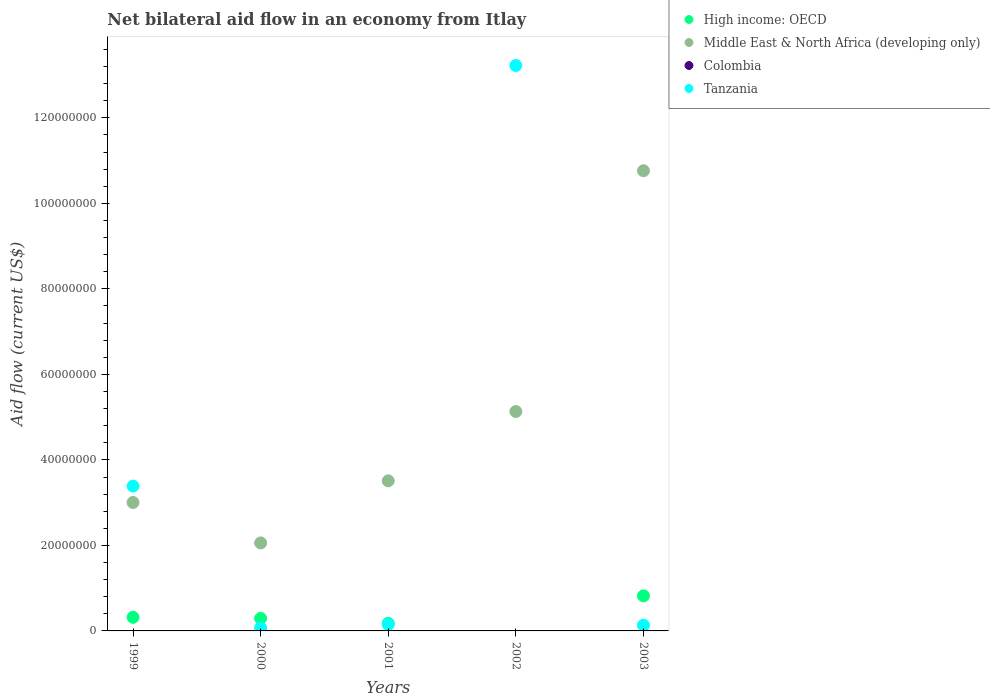How many different coloured dotlines are there?
Offer a terse response. 3. Across all years, what is the maximum net bilateral aid flow in High income: OECD?
Ensure brevity in your answer.  8.20e+06. Across all years, what is the minimum net bilateral aid flow in High income: OECD?
Your answer should be compact. 0. What is the total net bilateral aid flow in Tanzania in the graph?
Offer a very short reply. 1.70e+08. What is the difference between the net bilateral aid flow in Tanzania in 1999 and that in 2001?
Give a very brief answer. 3.24e+07. What is the difference between the net bilateral aid flow in High income: OECD in 2001 and the net bilateral aid flow in Colombia in 2000?
Give a very brief answer. 1.77e+06. What is the average net bilateral aid flow in Colombia per year?
Your response must be concise. 0. In the year 2003, what is the difference between the net bilateral aid flow in Tanzania and net bilateral aid flow in High income: OECD?
Your response must be concise. -6.86e+06. In how many years, is the net bilateral aid flow in Colombia greater than 80000000 US$?
Give a very brief answer. 0. What is the ratio of the net bilateral aid flow in Middle East & North Africa (developing only) in 2000 to that in 2003?
Your answer should be very brief. 0.19. Is the net bilateral aid flow in Tanzania in 2001 less than that in 2003?
Your answer should be very brief. No. Is the difference between the net bilateral aid flow in Tanzania in 2001 and 2003 greater than the difference between the net bilateral aid flow in High income: OECD in 2001 and 2003?
Ensure brevity in your answer.  Yes. What is the difference between the highest and the second highest net bilateral aid flow in High income: OECD?
Ensure brevity in your answer.  5.02e+06. What is the difference between the highest and the lowest net bilateral aid flow in Tanzania?
Your answer should be very brief. 1.32e+08. Is the sum of the net bilateral aid flow in Tanzania in 1999 and 2002 greater than the maximum net bilateral aid flow in High income: OECD across all years?
Your answer should be compact. Yes. Is it the case that in every year, the sum of the net bilateral aid flow in Colombia and net bilateral aid flow in High income: OECD  is greater than the sum of net bilateral aid flow in Tanzania and net bilateral aid flow in Middle East & North Africa (developing only)?
Offer a terse response. No. Does the net bilateral aid flow in Colombia monotonically increase over the years?
Give a very brief answer. No. Is the net bilateral aid flow in High income: OECD strictly less than the net bilateral aid flow in Colombia over the years?
Keep it short and to the point. No. How many years are there in the graph?
Give a very brief answer. 5. What is the difference between two consecutive major ticks on the Y-axis?
Your answer should be compact. 2.00e+07. Does the graph contain grids?
Ensure brevity in your answer.  No. Where does the legend appear in the graph?
Provide a short and direct response. Top right. How many legend labels are there?
Offer a terse response. 4. How are the legend labels stacked?
Ensure brevity in your answer.  Vertical. What is the title of the graph?
Your response must be concise. Net bilateral aid flow in an economy from Itlay. What is the label or title of the X-axis?
Ensure brevity in your answer.  Years. What is the Aid flow (current US$) in High income: OECD in 1999?
Keep it short and to the point. 3.18e+06. What is the Aid flow (current US$) of Middle East & North Africa (developing only) in 1999?
Your answer should be compact. 3.00e+07. What is the Aid flow (current US$) in Tanzania in 1999?
Offer a very short reply. 3.39e+07. What is the Aid flow (current US$) in High income: OECD in 2000?
Your answer should be compact. 2.94e+06. What is the Aid flow (current US$) of Middle East & North Africa (developing only) in 2000?
Give a very brief answer. 2.06e+07. What is the Aid flow (current US$) in Tanzania in 2000?
Ensure brevity in your answer.  6.90e+05. What is the Aid flow (current US$) in High income: OECD in 2001?
Your answer should be compact. 1.77e+06. What is the Aid flow (current US$) of Middle East & North Africa (developing only) in 2001?
Keep it short and to the point. 3.51e+07. What is the Aid flow (current US$) of Colombia in 2001?
Provide a succinct answer. 0. What is the Aid flow (current US$) of Tanzania in 2001?
Keep it short and to the point. 1.51e+06. What is the Aid flow (current US$) in Middle East & North Africa (developing only) in 2002?
Keep it short and to the point. 5.13e+07. What is the Aid flow (current US$) in Colombia in 2002?
Make the answer very short. 0. What is the Aid flow (current US$) of Tanzania in 2002?
Ensure brevity in your answer.  1.32e+08. What is the Aid flow (current US$) in High income: OECD in 2003?
Provide a short and direct response. 8.20e+06. What is the Aid flow (current US$) of Middle East & North Africa (developing only) in 2003?
Offer a very short reply. 1.08e+08. What is the Aid flow (current US$) in Colombia in 2003?
Offer a terse response. 0. What is the Aid flow (current US$) in Tanzania in 2003?
Provide a succinct answer. 1.34e+06. Across all years, what is the maximum Aid flow (current US$) in High income: OECD?
Your answer should be very brief. 8.20e+06. Across all years, what is the maximum Aid flow (current US$) of Middle East & North Africa (developing only)?
Your answer should be compact. 1.08e+08. Across all years, what is the maximum Aid flow (current US$) of Tanzania?
Make the answer very short. 1.32e+08. Across all years, what is the minimum Aid flow (current US$) of Middle East & North Africa (developing only)?
Provide a short and direct response. 2.06e+07. Across all years, what is the minimum Aid flow (current US$) in Tanzania?
Your answer should be compact. 6.90e+05. What is the total Aid flow (current US$) of High income: OECD in the graph?
Your response must be concise. 1.61e+07. What is the total Aid flow (current US$) in Middle East & North Africa (developing only) in the graph?
Keep it short and to the point. 2.45e+08. What is the total Aid flow (current US$) in Colombia in the graph?
Offer a terse response. 0. What is the total Aid flow (current US$) of Tanzania in the graph?
Offer a terse response. 1.70e+08. What is the difference between the Aid flow (current US$) of High income: OECD in 1999 and that in 2000?
Provide a short and direct response. 2.40e+05. What is the difference between the Aid flow (current US$) of Middle East & North Africa (developing only) in 1999 and that in 2000?
Offer a terse response. 9.46e+06. What is the difference between the Aid flow (current US$) of Tanzania in 1999 and that in 2000?
Your answer should be compact. 3.32e+07. What is the difference between the Aid flow (current US$) of High income: OECD in 1999 and that in 2001?
Provide a short and direct response. 1.41e+06. What is the difference between the Aid flow (current US$) of Middle East & North Africa (developing only) in 1999 and that in 2001?
Offer a terse response. -5.06e+06. What is the difference between the Aid flow (current US$) in Tanzania in 1999 and that in 2001?
Make the answer very short. 3.24e+07. What is the difference between the Aid flow (current US$) of Middle East & North Africa (developing only) in 1999 and that in 2002?
Ensure brevity in your answer.  -2.13e+07. What is the difference between the Aid flow (current US$) in Tanzania in 1999 and that in 2002?
Offer a terse response. -9.84e+07. What is the difference between the Aid flow (current US$) of High income: OECD in 1999 and that in 2003?
Keep it short and to the point. -5.02e+06. What is the difference between the Aid flow (current US$) in Middle East & North Africa (developing only) in 1999 and that in 2003?
Your answer should be very brief. -7.76e+07. What is the difference between the Aid flow (current US$) of Tanzania in 1999 and that in 2003?
Offer a terse response. 3.25e+07. What is the difference between the Aid flow (current US$) in High income: OECD in 2000 and that in 2001?
Keep it short and to the point. 1.17e+06. What is the difference between the Aid flow (current US$) of Middle East & North Africa (developing only) in 2000 and that in 2001?
Make the answer very short. -1.45e+07. What is the difference between the Aid flow (current US$) in Tanzania in 2000 and that in 2001?
Keep it short and to the point. -8.20e+05. What is the difference between the Aid flow (current US$) of Middle East & North Africa (developing only) in 2000 and that in 2002?
Provide a succinct answer. -3.07e+07. What is the difference between the Aid flow (current US$) of Tanzania in 2000 and that in 2002?
Give a very brief answer. -1.32e+08. What is the difference between the Aid flow (current US$) of High income: OECD in 2000 and that in 2003?
Give a very brief answer. -5.26e+06. What is the difference between the Aid flow (current US$) of Middle East & North Africa (developing only) in 2000 and that in 2003?
Your response must be concise. -8.70e+07. What is the difference between the Aid flow (current US$) of Tanzania in 2000 and that in 2003?
Offer a terse response. -6.50e+05. What is the difference between the Aid flow (current US$) of Middle East & North Africa (developing only) in 2001 and that in 2002?
Your answer should be very brief. -1.62e+07. What is the difference between the Aid flow (current US$) in Tanzania in 2001 and that in 2002?
Make the answer very short. -1.31e+08. What is the difference between the Aid flow (current US$) of High income: OECD in 2001 and that in 2003?
Make the answer very short. -6.43e+06. What is the difference between the Aid flow (current US$) in Middle East & North Africa (developing only) in 2001 and that in 2003?
Provide a short and direct response. -7.25e+07. What is the difference between the Aid flow (current US$) of Middle East & North Africa (developing only) in 2002 and that in 2003?
Your answer should be compact. -5.63e+07. What is the difference between the Aid flow (current US$) in Tanzania in 2002 and that in 2003?
Give a very brief answer. 1.31e+08. What is the difference between the Aid flow (current US$) of High income: OECD in 1999 and the Aid flow (current US$) of Middle East & North Africa (developing only) in 2000?
Provide a succinct answer. -1.74e+07. What is the difference between the Aid flow (current US$) in High income: OECD in 1999 and the Aid flow (current US$) in Tanzania in 2000?
Your answer should be very brief. 2.49e+06. What is the difference between the Aid flow (current US$) of Middle East & North Africa (developing only) in 1999 and the Aid flow (current US$) of Tanzania in 2000?
Your answer should be very brief. 2.94e+07. What is the difference between the Aid flow (current US$) of High income: OECD in 1999 and the Aid flow (current US$) of Middle East & North Africa (developing only) in 2001?
Provide a succinct answer. -3.19e+07. What is the difference between the Aid flow (current US$) in High income: OECD in 1999 and the Aid flow (current US$) in Tanzania in 2001?
Make the answer very short. 1.67e+06. What is the difference between the Aid flow (current US$) in Middle East & North Africa (developing only) in 1999 and the Aid flow (current US$) in Tanzania in 2001?
Your response must be concise. 2.85e+07. What is the difference between the Aid flow (current US$) in High income: OECD in 1999 and the Aid flow (current US$) in Middle East & North Africa (developing only) in 2002?
Your answer should be compact. -4.81e+07. What is the difference between the Aid flow (current US$) in High income: OECD in 1999 and the Aid flow (current US$) in Tanzania in 2002?
Your response must be concise. -1.29e+08. What is the difference between the Aid flow (current US$) in Middle East & North Africa (developing only) in 1999 and the Aid flow (current US$) in Tanzania in 2002?
Your answer should be compact. -1.02e+08. What is the difference between the Aid flow (current US$) of High income: OECD in 1999 and the Aid flow (current US$) of Middle East & North Africa (developing only) in 2003?
Provide a succinct answer. -1.04e+08. What is the difference between the Aid flow (current US$) in High income: OECD in 1999 and the Aid flow (current US$) in Tanzania in 2003?
Your response must be concise. 1.84e+06. What is the difference between the Aid flow (current US$) of Middle East & North Africa (developing only) in 1999 and the Aid flow (current US$) of Tanzania in 2003?
Provide a succinct answer. 2.87e+07. What is the difference between the Aid flow (current US$) in High income: OECD in 2000 and the Aid flow (current US$) in Middle East & North Africa (developing only) in 2001?
Your answer should be compact. -3.22e+07. What is the difference between the Aid flow (current US$) in High income: OECD in 2000 and the Aid flow (current US$) in Tanzania in 2001?
Provide a succinct answer. 1.43e+06. What is the difference between the Aid flow (current US$) of Middle East & North Africa (developing only) in 2000 and the Aid flow (current US$) of Tanzania in 2001?
Give a very brief answer. 1.91e+07. What is the difference between the Aid flow (current US$) of High income: OECD in 2000 and the Aid flow (current US$) of Middle East & North Africa (developing only) in 2002?
Your response must be concise. -4.84e+07. What is the difference between the Aid flow (current US$) in High income: OECD in 2000 and the Aid flow (current US$) in Tanzania in 2002?
Ensure brevity in your answer.  -1.29e+08. What is the difference between the Aid flow (current US$) in Middle East & North Africa (developing only) in 2000 and the Aid flow (current US$) in Tanzania in 2002?
Provide a succinct answer. -1.12e+08. What is the difference between the Aid flow (current US$) of High income: OECD in 2000 and the Aid flow (current US$) of Middle East & North Africa (developing only) in 2003?
Give a very brief answer. -1.05e+08. What is the difference between the Aid flow (current US$) in High income: OECD in 2000 and the Aid flow (current US$) in Tanzania in 2003?
Offer a very short reply. 1.60e+06. What is the difference between the Aid flow (current US$) in Middle East & North Africa (developing only) in 2000 and the Aid flow (current US$) in Tanzania in 2003?
Your answer should be compact. 1.92e+07. What is the difference between the Aid flow (current US$) of High income: OECD in 2001 and the Aid flow (current US$) of Middle East & North Africa (developing only) in 2002?
Ensure brevity in your answer.  -4.96e+07. What is the difference between the Aid flow (current US$) of High income: OECD in 2001 and the Aid flow (current US$) of Tanzania in 2002?
Make the answer very short. -1.30e+08. What is the difference between the Aid flow (current US$) in Middle East & North Africa (developing only) in 2001 and the Aid flow (current US$) in Tanzania in 2002?
Ensure brevity in your answer.  -9.72e+07. What is the difference between the Aid flow (current US$) in High income: OECD in 2001 and the Aid flow (current US$) in Middle East & North Africa (developing only) in 2003?
Your answer should be very brief. -1.06e+08. What is the difference between the Aid flow (current US$) of Middle East & North Africa (developing only) in 2001 and the Aid flow (current US$) of Tanzania in 2003?
Offer a very short reply. 3.38e+07. What is the difference between the Aid flow (current US$) of Middle East & North Africa (developing only) in 2002 and the Aid flow (current US$) of Tanzania in 2003?
Offer a very short reply. 5.00e+07. What is the average Aid flow (current US$) of High income: OECD per year?
Your response must be concise. 3.22e+06. What is the average Aid flow (current US$) in Middle East & North Africa (developing only) per year?
Provide a succinct answer. 4.89e+07. What is the average Aid flow (current US$) in Tanzania per year?
Make the answer very short. 3.39e+07. In the year 1999, what is the difference between the Aid flow (current US$) in High income: OECD and Aid flow (current US$) in Middle East & North Africa (developing only)?
Keep it short and to the point. -2.69e+07. In the year 1999, what is the difference between the Aid flow (current US$) of High income: OECD and Aid flow (current US$) of Tanzania?
Give a very brief answer. -3.07e+07. In the year 1999, what is the difference between the Aid flow (current US$) of Middle East & North Africa (developing only) and Aid flow (current US$) of Tanzania?
Your answer should be very brief. -3.83e+06. In the year 2000, what is the difference between the Aid flow (current US$) in High income: OECD and Aid flow (current US$) in Middle East & North Africa (developing only)?
Keep it short and to the point. -1.76e+07. In the year 2000, what is the difference between the Aid flow (current US$) of High income: OECD and Aid flow (current US$) of Tanzania?
Provide a succinct answer. 2.25e+06. In the year 2000, what is the difference between the Aid flow (current US$) of Middle East & North Africa (developing only) and Aid flow (current US$) of Tanzania?
Provide a succinct answer. 1.99e+07. In the year 2001, what is the difference between the Aid flow (current US$) in High income: OECD and Aid flow (current US$) in Middle East & North Africa (developing only)?
Offer a very short reply. -3.33e+07. In the year 2001, what is the difference between the Aid flow (current US$) in Middle East & North Africa (developing only) and Aid flow (current US$) in Tanzania?
Offer a very short reply. 3.36e+07. In the year 2002, what is the difference between the Aid flow (current US$) in Middle East & North Africa (developing only) and Aid flow (current US$) in Tanzania?
Ensure brevity in your answer.  -8.09e+07. In the year 2003, what is the difference between the Aid flow (current US$) in High income: OECD and Aid flow (current US$) in Middle East & North Africa (developing only)?
Your answer should be very brief. -9.94e+07. In the year 2003, what is the difference between the Aid flow (current US$) of High income: OECD and Aid flow (current US$) of Tanzania?
Give a very brief answer. 6.86e+06. In the year 2003, what is the difference between the Aid flow (current US$) of Middle East & North Africa (developing only) and Aid flow (current US$) of Tanzania?
Keep it short and to the point. 1.06e+08. What is the ratio of the Aid flow (current US$) in High income: OECD in 1999 to that in 2000?
Offer a terse response. 1.08. What is the ratio of the Aid flow (current US$) in Middle East & North Africa (developing only) in 1999 to that in 2000?
Offer a very short reply. 1.46. What is the ratio of the Aid flow (current US$) in Tanzania in 1999 to that in 2000?
Provide a short and direct response. 49.09. What is the ratio of the Aid flow (current US$) in High income: OECD in 1999 to that in 2001?
Ensure brevity in your answer.  1.8. What is the ratio of the Aid flow (current US$) in Middle East & North Africa (developing only) in 1999 to that in 2001?
Your response must be concise. 0.86. What is the ratio of the Aid flow (current US$) of Tanzania in 1999 to that in 2001?
Your response must be concise. 22.43. What is the ratio of the Aid flow (current US$) in Middle East & North Africa (developing only) in 1999 to that in 2002?
Ensure brevity in your answer.  0.59. What is the ratio of the Aid flow (current US$) in Tanzania in 1999 to that in 2002?
Give a very brief answer. 0.26. What is the ratio of the Aid flow (current US$) of High income: OECD in 1999 to that in 2003?
Offer a very short reply. 0.39. What is the ratio of the Aid flow (current US$) in Middle East & North Africa (developing only) in 1999 to that in 2003?
Give a very brief answer. 0.28. What is the ratio of the Aid flow (current US$) in Tanzania in 1999 to that in 2003?
Your answer should be compact. 25.28. What is the ratio of the Aid flow (current US$) in High income: OECD in 2000 to that in 2001?
Offer a very short reply. 1.66. What is the ratio of the Aid flow (current US$) in Middle East & North Africa (developing only) in 2000 to that in 2001?
Give a very brief answer. 0.59. What is the ratio of the Aid flow (current US$) of Tanzania in 2000 to that in 2001?
Make the answer very short. 0.46. What is the ratio of the Aid flow (current US$) of Middle East & North Africa (developing only) in 2000 to that in 2002?
Give a very brief answer. 0.4. What is the ratio of the Aid flow (current US$) of Tanzania in 2000 to that in 2002?
Your response must be concise. 0.01. What is the ratio of the Aid flow (current US$) in High income: OECD in 2000 to that in 2003?
Your answer should be compact. 0.36. What is the ratio of the Aid flow (current US$) in Middle East & North Africa (developing only) in 2000 to that in 2003?
Provide a short and direct response. 0.19. What is the ratio of the Aid flow (current US$) in Tanzania in 2000 to that in 2003?
Offer a very short reply. 0.51. What is the ratio of the Aid flow (current US$) in Middle East & North Africa (developing only) in 2001 to that in 2002?
Offer a very short reply. 0.68. What is the ratio of the Aid flow (current US$) of Tanzania in 2001 to that in 2002?
Ensure brevity in your answer.  0.01. What is the ratio of the Aid flow (current US$) of High income: OECD in 2001 to that in 2003?
Keep it short and to the point. 0.22. What is the ratio of the Aid flow (current US$) in Middle East & North Africa (developing only) in 2001 to that in 2003?
Offer a very short reply. 0.33. What is the ratio of the Aid flow (current US$) of Tanzania in 2001 to that in 2003?
Make the answer very short. 1.13. What is the ratio of the Aid flow (current US$) in Middle East & North Africa (developing only) in 2002 to that in 2003?
Make the answer very short. 0.48. What is the ratio of the Aid flow (current US$) of Tanzania in 2002 to that in 2003?
Offer a terse response. 98.69. What is the difference between the highest and the second highest Aid flow (current US$) of High income: OECD?
Ensure brevity in your answer.  5.02e+06. What is the difference between the highest and the second highest Aid flow (current US$) in Middle East & North Africa (developing only)?
Make the answer very short. 5.63e+07. What is the difference between the highest and the second highest Aid flow (current US$) of Tanzania?
Offer a very short reply. 9.84e+07. What is the difference between the highest and the lowest Aid flow (current US$) in High income: OECD?
Your response must be concise. 8.20e+06. What is the difference between the highest and the lowest Aid flow (current US$) in Middle East & North Africa (developing only)?
Your answer should be very brief. 8.70e+07. What is the difference between the highest and the lowest Aid flow (current US$) of Tanzania?
Your answer should be compact. 1.32e+08. 